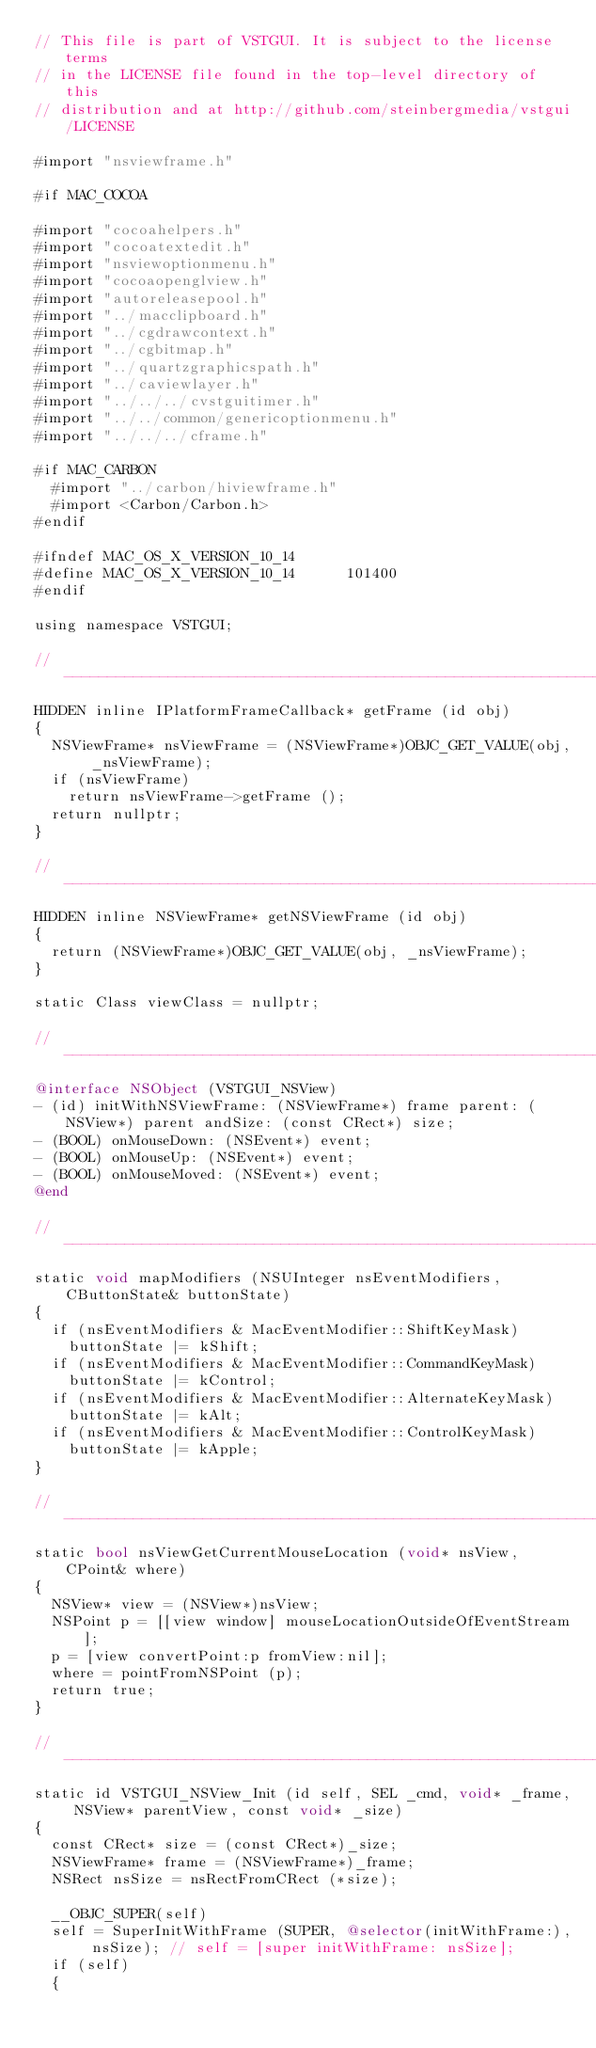<code> <loc_0><loc_0><loc_500><loc_500><_ObjectiveC_>// This file is part of VSTGUI. It is subject to the license terms 
// in the LICENSE file found in the top-level directory of this
// distribution and at http://github.com/steinbergmedia/vstgui/LICENSE

#import "nsviewframe.h"

#if MAC_COCOA

#import "cocoahelpers.h"
#import "cocoatextedit.h"
#import "nsviewoptionmenu.h"
#import "cocoaopenglview.h"
#import "autoreleasepool.h"
#import "../macclipboard.h"
#import "../cgdrawcontext.h"
#import "../cgbitmap.h"
#import "../quartzgraphicspath.h"
#import "../caviewlayer.h"
#import "../../../cvstguitimer.h"
#import "../../common/genericoptionmenu.h"
#import "../../../cframe.h"

#if MAC_CARBON
	#import "../carbon/hiviewframe.h"
	#import <Carbon/Carbon.h>
#endif

#ifndef MAC_OS_X_VERSION_10_14
#define MAC_OS_X_VERSION_10_14      101400
#endif

using namespace VSTGUI;

//------------------------------------------------------------------------------------
HIDDEN inline IPlatformFrameCallback* getFrame (id obj)
{
	NSViewFrame* nsViewFrame = (NSViewFrame*)OBJC_GET_VALUE(obj, _nsViewFrame);
	if (nsViewFrame)
		return nsViewFrame->getFrame ();
	return nullptr;
}

//------------------------------------------------------------------------------------
HIDDEN inline NSViewFrame* getNSViewFrame (id obj)
{
	return (NSViewFrame*)OBJC_GET_VALUE(obj, _nsViewFrame);
}

static Class viewClass = nullptr;

//------------------------------------------------------------------------------------
@interface NSObject (VSTGUI_NSView)
- (id) initWithNSViewFrame: (NSViewFrame*) frame parent: (NSView*) parent andSize: (const CRect*) size;
- (BOOL) onMouseDown: (NSEvent*) event;
- (BOOL) onMouseUp: (NSEvent*) event;
- (BOOL) onMouseMoved: (NSEvent*) event;
@end

//------------------------------------------------------------------------------------
static void mapModifiers (NSUInteger nsEventModifiers, CButtonState& buttonState)
{
	if (nsEventModifiers & MacEventModifier::ShiftKeyMask)
		buttonState |= kShift;
	if (nsEventModifiers & MacEventModifier::CommandKeyMask)
		buttonState |= kControl;
	if (nsEventModifiers & MacEventModifier::AlternateKeyMask)
		buttonState |= kAlt;
	if (nsEventModifiers & MacEventModifier::ControlKeyMask)
		buttonState |= kApple;
}

//------------------------------------------------------------------------------------
static bool nsViewGetCurrentMouseLocation (void* nsView, CPoint& where)
{
	NSView* view = (NSView*)nsView;
	NSPoint p = [[view window] mouseLocationOutsideOfEventStream];
	p = [view convertPoint:p fromView:nil];
	where = pointFromNSPoint (p);
	return true;
}

//------------------------------------------------------------------------------------
static id VSTGUI_NSView_Init (id self, SEL _cmd, void* _frame, NSView* parentView, const void* _size)
{
	const CRect* size = (const CRect*)_size;
	NSViewFrame* frame = (NSViewFrame*)_frame;
	NSRect nsSize = nsRectFromCRect (*size);

	__OBJC_SUPER(self)
	self = SuperInitWithFrame (SUPER, @selector(initWithFrame:), nsSize); // self = [super initWithFrame: nsSize];
	if (self)
	{</code> 